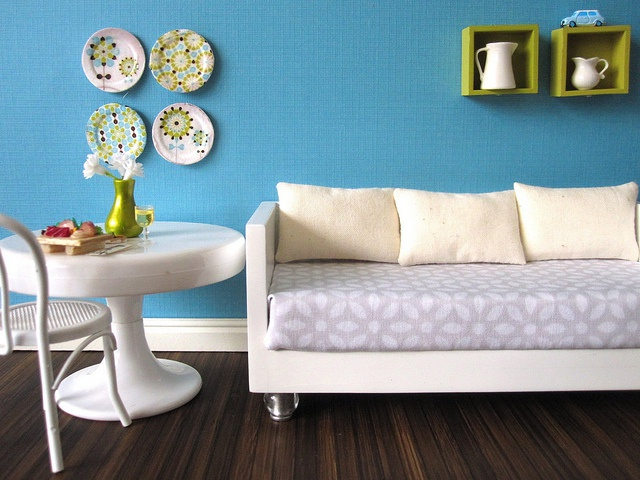Describe the objects in this image and their specific colors. I can see couch in lightblue, lightgray, darkgray, and tan tones, dining table in lightblue, lightgray, darkgray, and gray tones, chair in lightblue, lightgray, darkgray, and gray tones, vase in lightblue, olive, and yellow tones, and car in lightblue and gray tones in this image. 